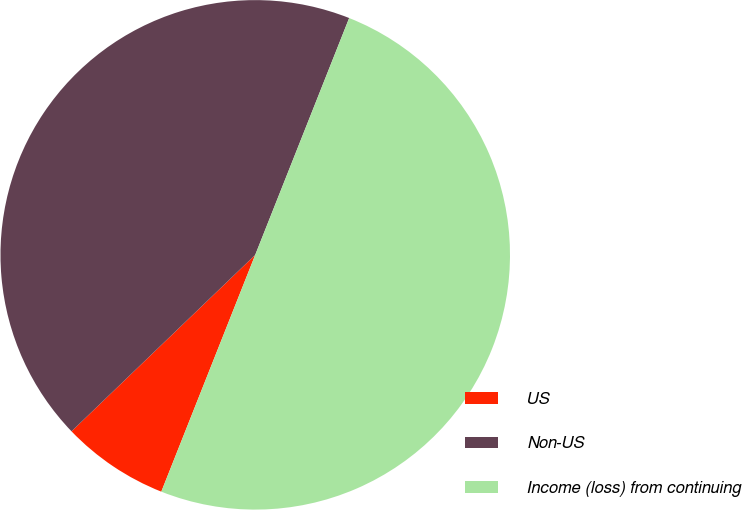<chart> <loc_0><loc_0><loc_500><loc_500><pie_chart><fcel>US<fcel>Non-US<fcel>Income (loss) from continuing<nl><fcel>6.81%<fcel>43.19%<fcel>50.0%<nl></chart> 